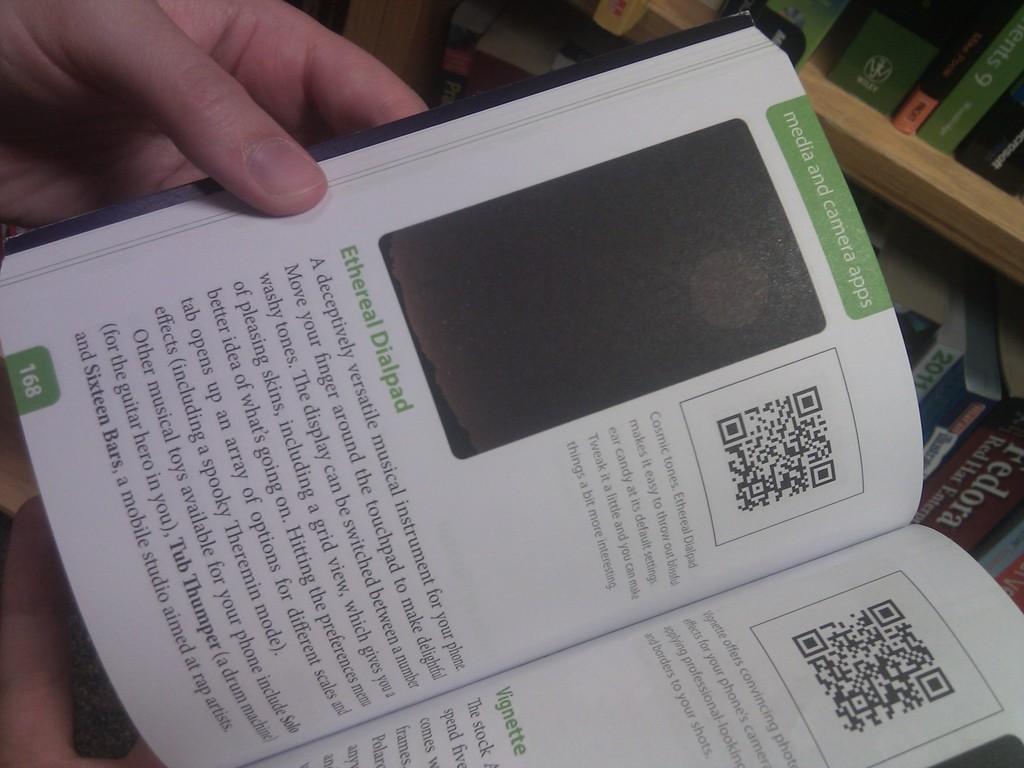What is the page number?
Keep it short and to the point. 168. 